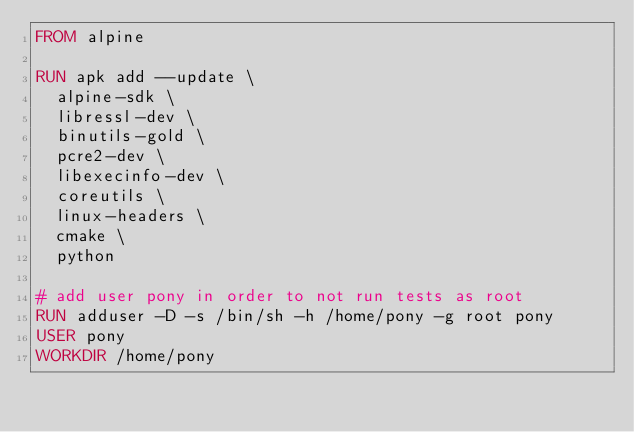Convert code to text. <code><loc_0><loc_0><loc_500><loc_500><_Dockerfile_>FROM alpine

RUN apk add --update \
  alpine-sdk \
  libressl-dev \
  binutils-gold \
  pcre2-dev \
  libexecinfo-dev \
  coreutils \
  linux-headers \
  cmake \
  python

# add user pony in order to not run tests as root
RUN adduser -D -s /bin/sh -h /home/pony -g root pony
USER pony
WORKDIR /home/pony
</code> 